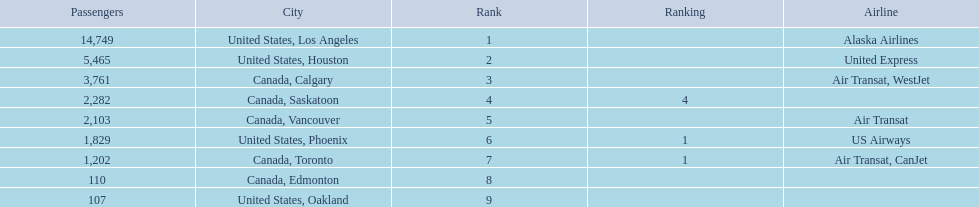What are all the cities? United States, Los Angeles, United States, Houston, Canada, Calgary, Canada, Saskatoon, Canada, Vancouver, United States, Phoenix, Canada, Toronto, Canada, Edmonton, United States, Oakland. How many passengers do they service? 14,749, 5,465, 3,761, 2,282, 2,103, 1,829, 1,202, 110, 107. Which city, when combined with los angeles, totals nearly 19,000? Canada, Calgary. 